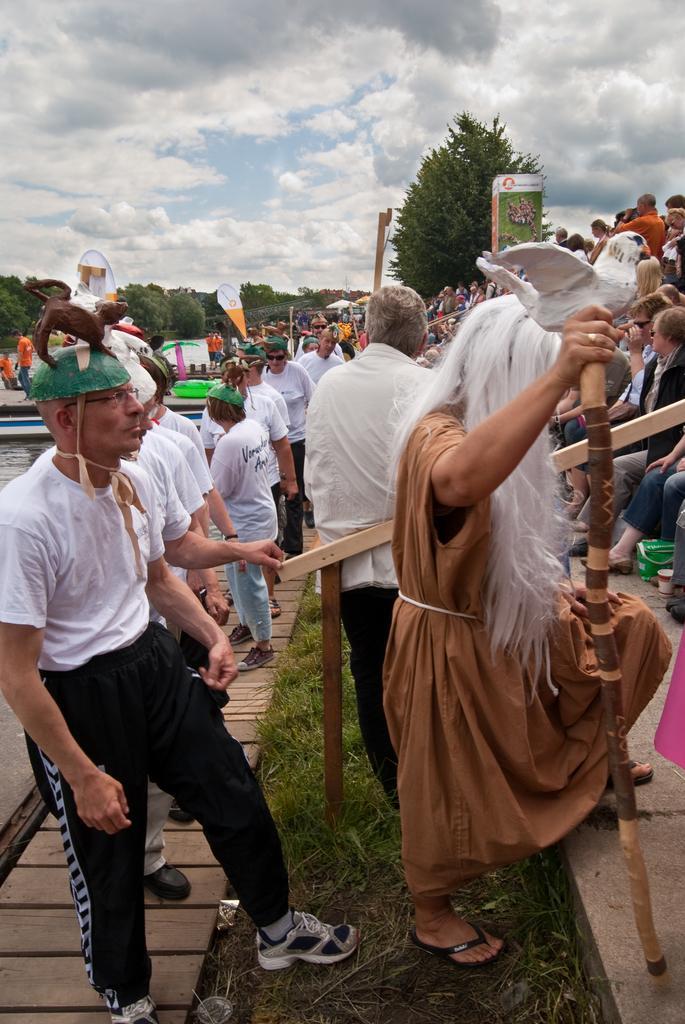Please provide a concise description of this image. In this image I can see number of people are standing and on the left side I can see most of them are wearing white colour dress and on their heads I can see a green colour thing. On the right side I can see one person is holding a stick. In the background I can see number of trees, few boards, clouds and the sky. 